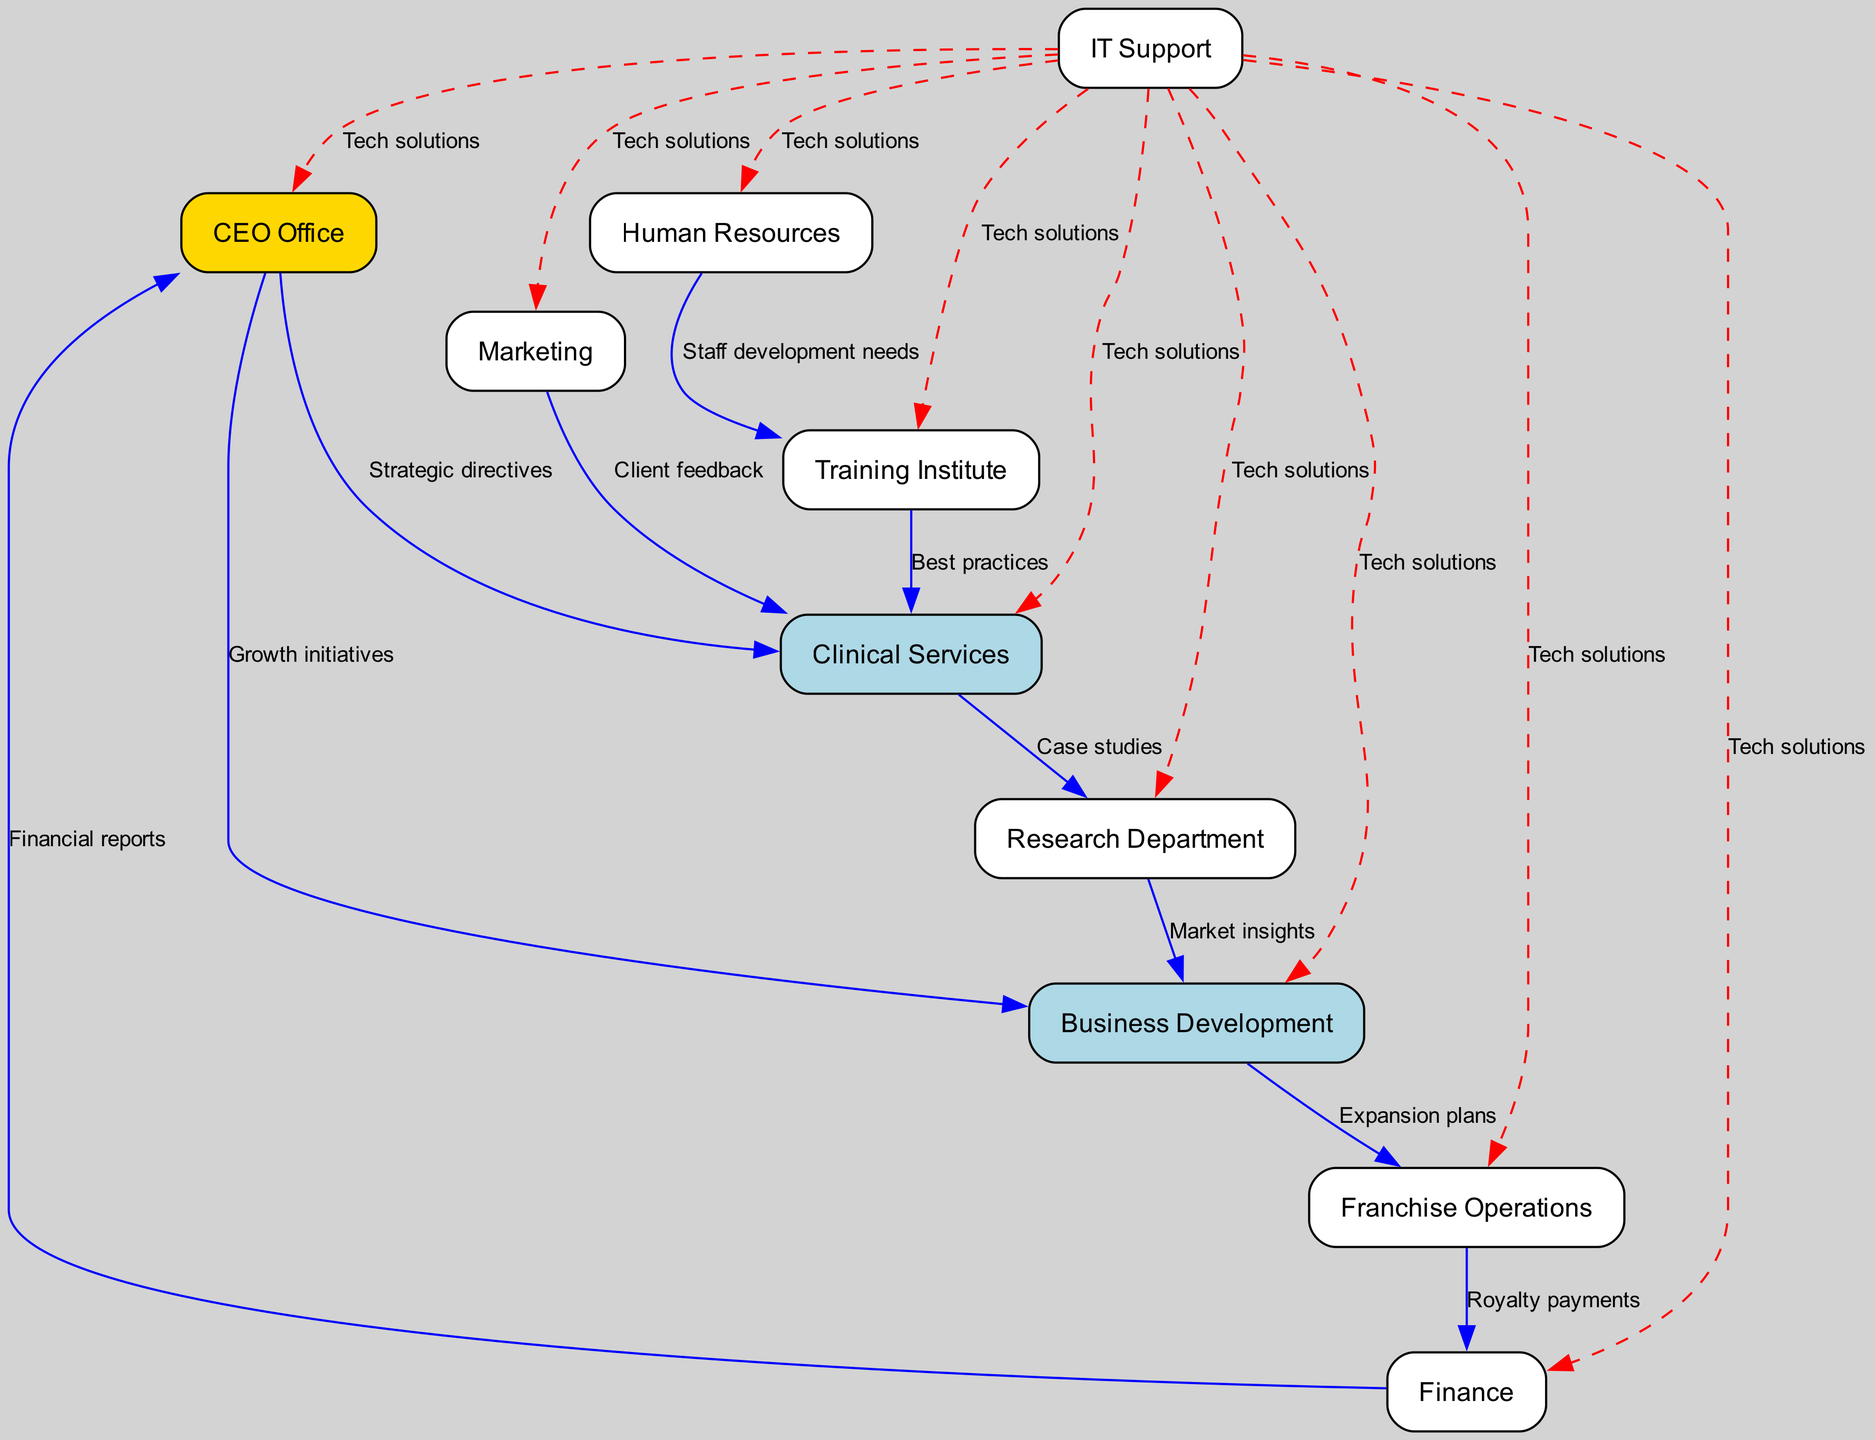What is the total number of nodes in the diagram? The diagram features a total of 10 distinct nodes representing various departments and entities. By counting the names listed in the "nodes" section of the provided data, we confirm there are 10 unique nodes.
Answer: 10 Which department receives strategic directives from the CEO Office? The directed edge from the "CEO Office" to "Clinical Services" indicates that "Clinical Services" receives strategic directives from the CEO Office. This can be seen directly on the diagram, where the edge label specifies the relationship.
Answer: Clinical Services What type of information flows from Clinical Services to the Research Department? An edge exists from "Clinical Services" to "Research Department" labeled as "Case studies," indicating that information about case studies travels from Clinical Services to the Research Department. The flow of information is clearly marked by the edge label.
Answer: Case studies How many departments have direct communication with the Finance department? The Finance department has two direct connections: one to the CEO Office (financial reports) and another from Franchise Operations (royalty payments). Counting these connections reveals two distinct pathways of communication.
Answer: 2 Which two departments are connected through market insights? The directed graph shows a flow of information from "Research Department" to "Business Development," labeled "Market insights." This relationship indicates these two departments are connected based on insights regarding the market.
Answer: Research Department and Business Development What role does IT Support play in the communication from other departments? IT Support is connected to "All Departments," with an edge labeled "Tech solutions." This indicates that IT Support provides technical solutions to every department, facilitating communication across the entire organization.
Answer: Tech solutions Which department communicates client feedback to Clinical Services? The diagram shows that "Marketing" communicates client feedback to "Clinical Services." This is indicated by the directed edge linking these two nodes along with its label.
Answer: Marketing What is the main purpose of the connection between Human Resources and Training Institute? The directed edge from "Human Resources" to "Training Institute" is labeled "Staff development needs," which signifies that Human Resources assesses and communicates the development needs of the staff to the Training Institute.
Answer: Staff development needs Which department is most centrally connected to the flow of information based on the edges? "Clinical Services" appears centrally connected, with two incoming edges (from "CEO Office" and "Marketing") and two outgoing edges (to "Research Department" and "Training Institute"). Assessing these connections suggests it plays a crucial role in information flow.
Answer: Clinical Services 